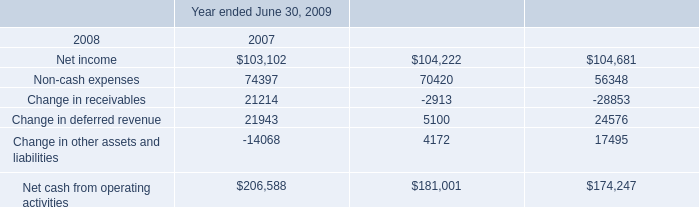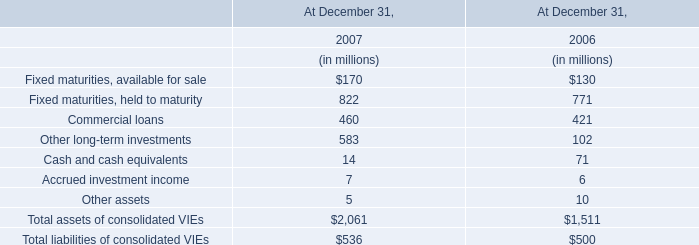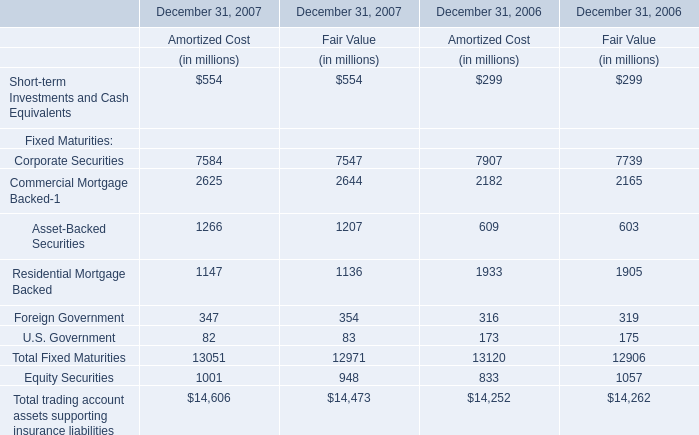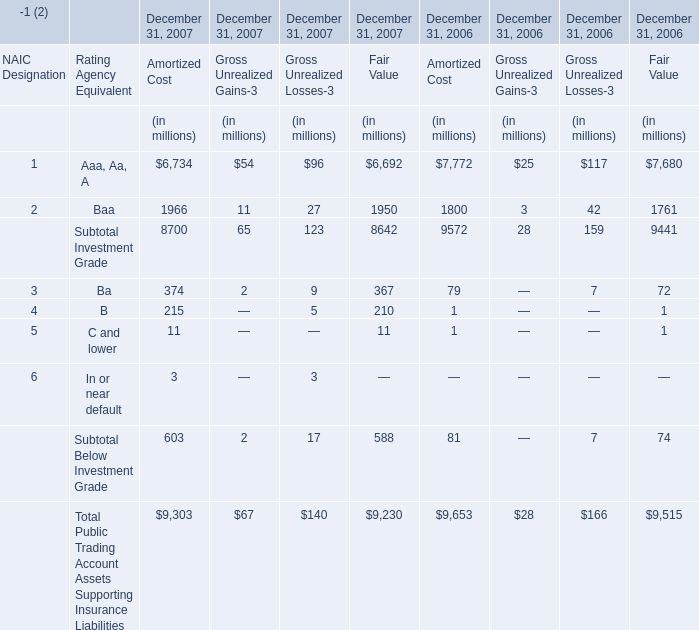Which year is Asset-Backed Securities for fair value the most? 
Answer: 2007. 